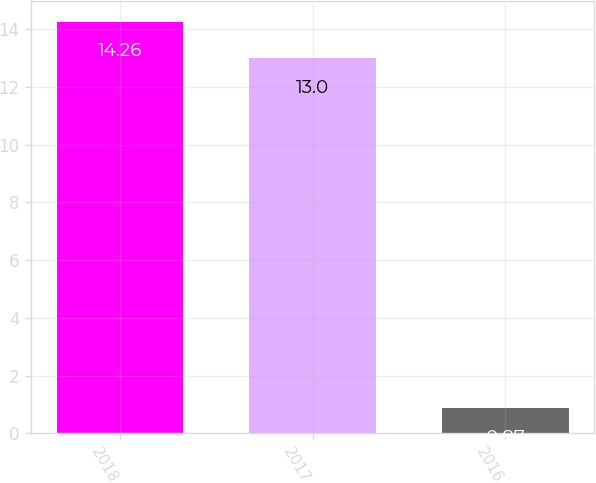Convert chart. <chart><loc_0><loc_0><loc_500><loc_500><bar_chart><fcel>2018<fcel>2017<fcel>2016<nl><fcel>14.26<fcel>13<fcel>0.87<nl></chart> 